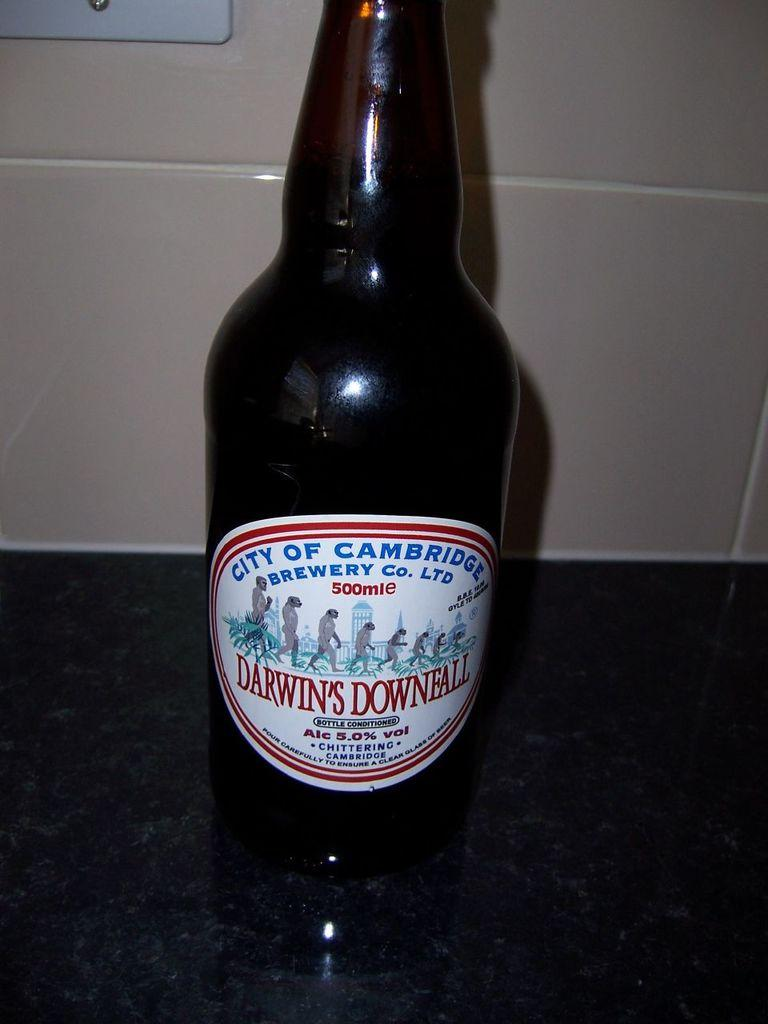<image>
Present a compact description of the photo's key features. A bottle of Darwin's Downfall is sitting on a table. 